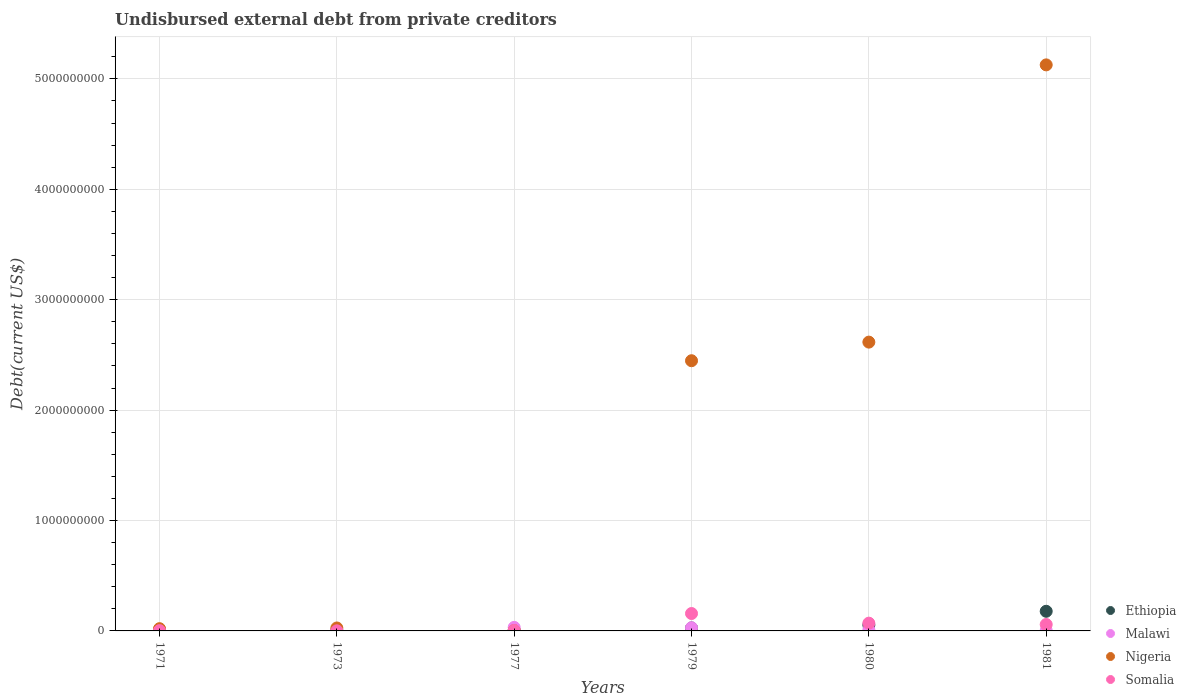How many different coloured dotlines are there?
Your answer should be very brief. 4. Is the number of dotlines equal to the number of legend labels?
Provide a succinct answer. Yes. What is the total debt in Ethiopia in 1980?
Provide a succinct answer. 5.35e+07. Across all years, what is the maximum total debt in Malawi?
Provide a succinct answer. 3.21e+07. Across all years, what is the minimum total debt in Somalia?
Keep it short and to the point. 1.00e+06. In which year was the total debt in Somalia maximum?
Offer a very short reply. 1979. In which year was the total debt in Ethiopia minimum?
Keep it short and to the point. 1971. What is the total total debt in Somalia in the graph?
Offer a terse response. 2.94e+08. What is the difference between the total debt in Malawi in 1971 and that in 1980?
Ensure brevity in your answer.  -3.56e+06. What is the difference between the total debt in Somalia in 1973 and the total debt in Ethiopia in 1977?
Offer a terse response. -5.89e+06. What is the average total debt in Malawi per year?
Offer a terse response. 1.36e+07. In the year 1973, what is the difference between the total debt in Somalia and total debt in Nigeria?
Make the answer very short. -2.57e+07. In how many years, is the total debt in Ethiopia greater than 3400000000 US$?
Provide a short and direct response. 0. What is the ratio of the total debt in Malawi in 1977 to that in 1980?
Keep it short and to the point. 3.21. Is the total debt in Somalia in 1971 less than that in 1973?
Your response must be concise. No. Is the difference between the total debt in Somalia in 1977 and 1979 greater than the difference between the total debt in Nigeria in 1977 and 1979?
Make the answer very short. Yes. What is the difference between the highest and the second highest total debt in Malawi?
Provide a short and direct response. 3.46e+06. What is the difference between the highest and the lowest total debt in Malawi?
Make the answer very short. 3.18e+07. Is the sum of the total debt in Malawi in 1973 and 1981 greater than the maximum total debt in Nigeria across all years?
Provide a succinct answer. No. Is it the case that in every year, the sum of the total debt in Somalia and total debt in Nigeria  is greater than the sum of total debt in Malawi and total debt in Ethiopia?
Give a very brief answer. No. How many dotlines are there?
Offer a terse response. 4. What is the difference between two consecutive major ticks on the Y-axis?
Make the answer very short. 1.00e+09. Does the graph contain any zero values?
Offer a very short reply. No. Does the graph contain grids?
Give a very brief answer. Yes. Where does the legend appear in the graph?
Provide a succinct answer. Bottom right. How many legend labels are there?
Provide a short and direct response. 4. What is the title of the graph?
Your answer should be compact. Undisbursed external debt from private creditors. Does "Palau" appear as one of the legend labels in the graph?
Provide a succinct answer. No. What is the label or title of the Y-axis?
Keep it short and to the point. Debt(current US$). What is the Debt(current US$) in Ethiopia in 1971?
Offer a very short reply. 1.16e+06. What is the Debt(current US$) of Malawi in 1971?
Ensure brevity in your answer.  6.45e+06. What is the Debt(current US$) of Nigeria in 1971?
Your response must be concise. 2.04e+07. What is the Debt(current US$) of Somalia in 1971?
Ensure brevity in your answer.  2.71e+06. What is the Debt(current US$) in Ethiopia in 1973?
Provide a succinct answer. 4.57e+06. What is the Debt(current US$) in Malawi in 1973?
Keep it short and to the point. 3.12e+05. What is the Debt(current US$) of Nigeria in 1973?
Provide a succinct answer. 2.67e+07. What is the Debt(current US$) in Somalia in 1973?
Offer a terse response. 1.00e+06. What is the Debt(current US$) in Ethiopia in 1977?
Ensure brevity in your answer.  6.89e+06. What is the Debt(current US$) of Malawi in 1977?
Your answer should be very brief. 3.21e+07. What is the Debt(current US$) in Nigeria in 1977?
Your answer should be very brief. 2.79e+06. What is the Debt(current US$) in Somalia in 1977?
Your response must be concise. 4.53e+06. What is the Debt(current US$) of Ethiopia in 1979?
Your response must be concise. 2.71e+07. What is the Debt(current US$) in Malawi in 1979?
Your answer should be compact. 2.87e+07. What is the Debt(current US$) in Nigeria in 1979?
Your response must be concise. 2.45e+09. What is the Debt(current US$) in Somalia in 1979?
Provide a short and direct response. 1.58e+08. What is the Debt(current US$) in Ethiopia in 1980?
Keep it short and to the point. 5.35e+07. What is the Debt(current US$) in Malawi in 1980?
Provide a succinct answer. 1.00e+07. What is the Debt(current US$) in Nigeria in 1980?
Keep it short and to the point. 2.62e+09. What is the Debt(current US$) of Somalia in 1980?
Make the answer very short. 7.03e+07. What is the Debt(current US$) of Ethiopia in 1981?
Your answer should be very brief. 1.78e+08. What is the Debt(current US$) of Malawi in 1981?
Provide a succinct answer. 3.81e+06. What is the Debt(current US$) in Nigeria in 1981?
Your response must be concise. 5.13e+09. What is the Debt(current US$) of Somalia in 1981?
Your response must be concise. 5.82e+07. Across all years, what is the maximum Debt(current US$) in Ethiopia?
Your answer should be very brief. 1.78e+08. Across all years, what is the maximum Debt(current US$) in Malawi?
Keep it short and to the point. 3.21e+07. Across all years, what is the maximum Debt(current US$) of Nigeria?
Provide a succinct answer. 5.13e+09. Across all years, what is the maximum Debt(current US$) in Somalia?
Offer a very short reply. 1.58e+08. Across all years, what is the minimum Debt(current US$) of Ethiopia?
Provide a short and direct response. 1.16e+06. Across all years, what is the minimum Debt(current US$) in Malawi?
Provide a short and direct response. 3.12e+05. Across all years, what is the minimum Debt(current US$) of Nigeria?
Your response must be concise. 2.79e+06. What is the total Debt(current US$) in Ethiopia in the graph?
Give a very brief answer. 2.71e+08. What is the total Debt(current US$) in Malawi in the graph?
Ensure brevity in your answer.  8.14e+07. What is the total Debt(current US$) in Nigeria in the graph?
Provide a succinct answer. 1.02e+1. What is the total Debt(current US$) of Somalia in the graph?
Your response must be concise. 2.94e+08. What is the difference between the Debt(current US$) of Ethiopia in 1971 and that in 1973?
Provide a short and direct response. -3.40e+06. What is the difference between the Debt(current US$) in Malawi in 1971 and that in 1973?
Give a very brief answer. 6.14e+06. What is the difference between the Debt(current US$) in Nigeria in 1971 and that in 1973?
Your response must be concise. -6.33e+06. What is the difference between the Debt(current US$) of Somalia in 1971 and that in 1973?
Your response must be concise. 1.71e+06. What is the difference between the Debt(current US$) of Ethiopia in 1971 and that in 1977?
Offer a terse response. -5.72e+06. What is the difference between the Debt(current US$) in Malawi in 1971 and that in 1977?
Make the answer very short. -2.57e+07. What is the difference between the Debt(current US$) in Nigeria in 1971 and that in 1977?
Keep it short and to the point. 1.76e+07. What is the difference between the Debt(current US$) of Somalia in 1971 and that in 1977?
Offer a terse response. -1.82e+06. What is the difference between the Debt(current US$) of Ethiopia in 1971 and that in 1979?
Offer a terse response. -2.60e+07. What is the difference between the Debt(current US$) in Malawi in 1971 and that in 1979?
Your response must be concise. -2.22e+07. What is the difference between the Debt(current US$) of Nigeria in 1971 and that in 1979?
Offer a terse response. -2.43e+09. What is the difference between the Debt(current US$) in Somalia in 1971 and that in 1979?
Keep it short and to the point. -1.55e+08. What is the difference between the Debt(current US$) of Ethiopia in 1971 and that in 1980?
Provide a succinct answer. -5.23e+07. What is the difference between the Debt(current US$) of Malawi in 1971 and that in 1980?
Your answer should be very brief. -3.56e+06. What is the difference between the Debt(current US$) of Nigeria in 1971 and that in 1980?
Provide a succinct answer. -2.60e+09. What is the difference between the Debt(current US$) of Somalia in 1971 and that in 1980?
Your response must be concise. -6.76e+07. What is the difference between the Debt(current US$) of Ethiopia in 1971 and that in 1981?
Make the answer very short. -1.77e+08. What is the difference between the Debt(current US$) in Malawi in 1971 and that in 1981?
Provide a short and direct response. 2.64e+06. What is the difference between the Debt(current US$) of Nigeria in 1971 and that in 1981?
Provide a succinct answer. -5.11e+09. What is the difference between the Debt(current US$) in Somalia in 1971 and that in 1981?
Your response must be concise. -5.55e+07. What is the difference between the Debt(current US$) of Ethiopia in 1973 and that in 1977?
Give a very brief answer. -2.32e+06. What is the difference between the Debt(current US$) of Malawi in 1973 and that in 1977?
Make the answer very short. -3.18e+07. What is the difference between the Debt(current US$) in Nigeria in 1973 and that in 1977?
Provide a short and direct response. 2.39e+07. What is the difference between the Debt(current US$) of Somalia in 1973 and that in 1977?
Offer a very short reply. -3.53e+06. What is the difference between the Debt(current US$) of Ethiopia in 1973 and that in 1979?
Your answer should be very brief. -2.26e+07. What is the difference between the Debt(current US$) in Malawi in 1973 and that in 1979?
Your answer should be compact. -2.84e+07. What is the difference between the Debt(current US$) in Nigeria in 1973 and that in 1979?
Give a very brief answer. -2.42e+09. What is the difference between the Debt(current US$) of Somalia in 1973 and that in 1979?
Provide a short and direct response. -1.57e+08. What is the difference between the Debt(current US$) in Ethiopia in 1973 and that in 1980?
Offer a terse response. -4.89e+07. What is the difference between the Debt(current US$) of Malawi in 1973 and that in 1980?
Your answer should be very brief. -9.70e+06. What is the difference between the Debt(current US$) of Nigeria in 1973 and that in 1980?
Provide a short and direct response. -2.59e+09. What is the difference between the Debt(current US$) of Somalia in 1973 and that in 1980?
Your answer should be very brief. -6.93e+07. What is the difference between the Debt(current US$) of Ethiopia in 1973 and that in 1981?
Your response must be concise. -1.73e+08. What is the difference between the Debt(current US$) of Malawi in 1973 and that in 1981?
Ensure brevity in your answer.  -3.50e+06. What is the difference between the Debt(current US$) of Nigeria in 1973 and that in 1981?
Your answer should be very brief. -5.10e+09. What is the difference between the Debt(current US$) in Somalia in 1973 and that in 1981?
Keep it short and to the point. -5.72e+07. What is the difference between the Debt(current US$) of Ethiopia in 1977 and that in 1979?
Make the answer very short. -2.02e+07. What is the difference between the Debt(current US$) of Malawi in 1977 and that in 1979?
Keep it short and to the point. 3.46e+06. What is the difference between the Debt(current US$) of Nigeria in 1977 and that in 1979?
Provide a succinct answer. -2.44e+09. What is the difference between the Debt(current US$) of Somalia in 1977 and that in 1979?
Provide a succinct answer. -1.53e+08. What is the difference between the Debt(current US$) of Ethiopia in 1977 and that in 1980?
Provide a short and direct response. -4.66e+07. What is the difference between the Debt(current US$) in Malawi in 1977 and that in 1980?
Ensure brevity in your answer.  2.21e+07. What is the difference between the Debt(current US$) of Nigeria in 1977 and that in 1980?
Your answer should be very brief. -2.61e+09. What is the difference between the Debt(current US$) in Somalia in 1977 and that in 1980?
Make the answer very short. -6.58e+07. What is the difference between the Debt(current US$) of Ethiopia in 1977 and that in 1981?
Provide a short and direct response. -1.71e+08. What is the difference between the Debt(current US$) of Malawi in 1977 and that in 1981?
Offer a very short reply. 2.83e+07. What is the difference between the Debt(current US$) of Nigeria in 1977 and that in 1981?
Offer a terse response. -5.12e+09. What is the difference between the Debt(current US$) in Somalia in 1977 and that in 1981?
Provide a short and direct response. -5.37e+07. What is the difference between the Debt(current US$) in Ethiopia in 1979 and that in 1980?
Provide a succinct answer. -2.64e+07. What is the difference between the Debt(current US$) in Malawi in 1979 and that in 1980?
Offer a terse response. 1.87e+07. What is the difference between the Debt(current US$) of Nigeria in 1979 and that in 1980?
Your response must be concise. -1.69e+08. What is the difference between the Debt(current US$) of Somalia in 1979 and that in 1980?
Your response must be concise. 8.73e+07. What is the difference between the Debt(current US$) of Ethiopia in 1979 and that in 1981?
Keep it short and to the point. -1.51e+08. What is the difference between the Debt(current US$) in Malawi in 1979 and that in 1981?
Provide a succinct answer. 2.49e+07. What is the difference between the Debt(current US$) in Nigeria in 1979 and that in 1981?
Make the answer very short. -2.68e+09. What is the difference between the Debt(current US$) in Somalia in 1979 and that in 1981?
Make the answer very short. 9.94e+07. What is the difference between the Debt(current US$) of Ethiopia in 1980 and that in 1981?
Make the answer very short. -1.24e+08. What is the difference between the Debt(current US$) of Malawi in 1980 and that in 1981?
Provide a succinct answer. 6.20e+06. What is the difference between the Debt(current US$) in Nigeria in 1980 and that in 1981?
Your answer should be very brief. -2.51e+09. What is the difference between the Debt(current US$) of Somalia in 1980 and that in 1981?
Provide a short and direct response. 1.21e+07. What is the difference between the Debt(current US$) of Ethiopia in 1971 and the Debt(current US$) of Malawi in 1973?
Your answer should be very brief. 8.53e+05. What is the difference between the Debt(current US$) in Ethiopia in 1971 and the Debt(current US$) in Nigeria in 1973?
Keep it short and to the point. -2.55e+07. What is the difference between the Debt(current US$) of Ethiopia in 1971 and the Debt(current US$) of Somalia in 1973?
Your answer should be compact. 1.65e+05. What is the difference between the Debt(current US$) of Malawi in 1971 and the Debt(current US$) of Nigeria in 1973?
Ensure brevity in your answer.  -2.02e+07. What is the difference between the Debt(current US$) in Malawi in 1971 and the Debt(current US$) in Somalia in 1973?
Give a very brief answer. 5.45e+06. What is the difference between the Debt(current US$) of Nigeria in 1971 and the Debt(current US$) of Somalia in 1973?
Offer a very short reply. 1.94e+07. What is the difference between the Debt(current US$) of Ethiopia in 1971 and the Debt(current US$) of Malawi in 1977?
Your answer should be compact. -3.10e+07. What is the difference between the Debt(current US$) of Ethiopia in 1971 and the Debt(current US$) of Nigeria in 1977?
Ensure brevity in your answer.  -1.62e+06. What is the difference between the Debt(current US$) of Ethiopia in 1971 and the Debt(current US$) of Somalia in 1977?
Your answer should be very brief. -3.36e+06. What is the difference between the Debt(current US$) in Malawi in 1971 and the Debt(current US$) in Nigeria in 1977?
Keep it short and to the point. 3.66e+06. What is the difference between the Debt(current US$) in Malawi in 1971 and the Debt(current US$) in Somalia in 1977?
Provide a succinct answer. 1.92e+06. What is the difference between the Debt(current US$) of Nigeria in 1971 and the Debt(current US$) of Somalia in 1977?
Offer a very short reply. 1.58e+07. What is the difference between the Debt(current US$) of Ethiopia in 1971 and the Debt(current US$) of Malawi in 1979?
Your answer should be compact. -2.75e+07. What is the difference between the Debt(current US$) of Ethiopia in 1971 and the Debt(current US$) of Nigeria in 1979?
Keep it short and to the point. -2.45e+09. What is the difference between the Debt(current US$) of Ethiopia in 1971 and the Debt(current US$) of Somalia in 1979?
Keep it short and to the point. -1.56e+08. What is the difference between the Debt(current US$) in Malawi in 1971 and the Debt(current US$) in Nigeria in 1979?
Provide a succinct answer. -2.44e+09. What is the difference between the Debt(current US$) in Malawi in 1971 and the Debt(current US$) in Somalia in 1979?
Provide a short and direct response. -1.51e+08. What is the difference between the Debt(current US$) of Nigeria in 1971 and the Debt(current US$) of Somalia in 1979?
Provide a short and direct response. -1.37e+08. What is the difference between the Debt(current US$) in Ethiopia in 1971 and the Debt(current US$) in Malawi in 1980?
Your answer should be very brief. -8.84e+06. What is the difference between the Debt(current US$) of Ethiopia in 1971 and the Debt(current US$) of Nigeria in 1980?
Offer a very short reply. -2.61e+09. What is the difference between the Debt(current US$) of Ethiopia in 1971 and the Debt(current US$) of Somalia in 1980?
Offer a very short reply. -6.92e+07. What is the difference between the Debt(current US$) in Malawi in 1971 and the Debt(current US$) in Nigeria in 1980?
Provide a short and direct response. -2.61e+09. What is the difference between the Debt(current US$) in Malawi in 1971 and the Debt(current US$) in Somalia in 1980?
Offer a terse response. -6.39e+07. What is the difference between the Debt(current US$) of Nigeria in 1971 and the Debt(current US$) of Somalia in 1980?
Your answer should be compact. -5.00e+07. What is the difference between the Debt(current US$) of Ethiopia in 1971 and the Debt(current US$) of Malawi in 1981?
Your answer should be compact. -2.65e+06. What is the difference between the Debt(current US$) in Ethiopia in 1971 and the Debt(current US$) in Nigeria in 1981?
Your response must be concise. -5.13e+09. What is the difference between the Debt(current US$) in Ethiopia in 1971 and the Debt(current US$) in Somalia in 1981?
Ensure brevity in your answer.  -5.70e+07. What is the difference between the Debt(current US$) in Malawi in 1971 and the Debt(current US$) in Nigeria in 1981?
Your answer should be compact. -5.12e+09. What is the difference between the Debt(current US$) in Malawi in 1971 and the Debt(current US$) in Somalia in 1981?
Your answer should be compact. -5.17e+07. What is the difference between the Debt(current US$) in Nigeria in 1971 and the Debt(current US$) in Somalia in 1981?
Provide a short and direct response. -3.78e+07. What is the difference between the Debt(current US$) of Ethiopia in 1973 and the Debt(current US$) of Malawi in 1977?
Keep it short and to the point. -2.76e+07. What is the difference between the Debt(current US$) in Ethiopia in 1973 and the Debt(current US$) in Nigeria in 1977?
Offer a very short reply. 1.78e+06. What is the difference between the Debt(current US$) in Ethiopia in 1973 and the Debt(current US$) in Somalia in 1977?
Ensure brevity in your answer.  3.90e+04. What is the difference between the Debt(current US$) of Malawi in 1973 and the Debt(current US$) of Nigeria in 1977?
Ensure brevity in your answer.  -2.47e+06. What is the difference between the Debt(current US$) in Malawi in 1973 and the Debt(current US$) in Somalia in 1977?
Your answer should be very brief. -4.22e+06. What is the difference between the Debt(current US$) in Nigeria in 1973 and the Debt(current US$) in Somalia in 1977?
Make the answer very short. 2.22e+07. What is the difference between the Debt(current US$) of Ethiopia in 1973 and the Debt(current US$) of Malawi in 1979?
Offer a terse response. -2.41e+07. What is the difference between the Debt(current US$) in Ethiopia in 1973 and the Debt(current US$) in Nigeria in 1979?
Your answer should be very brief. -2.44e+09. What is the difference between the Debt(current US$) in Ethiopia in 1973 and the Debt(current US$) in Somalia in 1979?
Your answer should be very brief. -1.53e+08. What is the difference between the Debt(current US$) in Malawi in 1973 and the Debt(current US$) in Nigeria in 1979?
Offer a very short reply. -2.45e+09. What is the difference between the Debt(current US$) in Malawi in 1973 and the Debt(current US$) in Somalia in 1979?
Your response must be concise. -1.57e+08. What is the difference between the Debt(current US$) of Nigeria in 1973 and the Debt(current US$) of Somalia in 1979?
Offer a terse response. -1.31e+08. What is the difference between the Debt(current US$) of Ethiopia in 1973 and the Debt(current US$) of Malawi in 1980?
Make the answer very short. -5.44e+06. What is the difference between the Debt(current US$) in Ethiopia in 1973 and the Debt(current US$) in Nigeria in 1980?
Make the answer very short. -2.61e+09. What is the difference between the Debt(current US$) in Ethiopia in 1973 and the Debt(current US$) in Somalia in 1980?
Give a very brief answer. -6.58e+07. What is the difference between the Debt(current US$) in Malawi in 1973 and the Debt(current US$) in Nigeria in 1980?
Provide a short and direct response. -2.62e+09. What is the difference between the Debt(current US$) of Malawi in 1973 and the Debt(current US$) of Somalia in 1980?
Offer a terse response. -7.00e+07. What is the difference between the Debt(current US$) in Nigeria in 1973 and the Debt(current US$) in Somalia in 1980?
Make the answer very short. -4.36e+07. What is the difference between the Debt(current US$) in Ethiopia in 1973 and the Debt(current US$) in Malawi in 1981?
Make the answer very short. 7.56e+05. What is the difference between the Debt(current US$) of Ethiopia in 1973 and the Debt(current US$) of Nigeria in 1981?
Provide a short and direct response. -5.12e+09. What is the difference between the Debt(current US$) of Ethiopia in 1973 and the Debt(current US$) of Somalia in 1981?
Make the answer very short. -5.36e+07. What is the difference between the Debt(current US$) of Malawi in 1973 and the Debt(current US$) of Nigeria in 1981?
Your answer should be very brief. -5.13e+09. What is the difference between the Debt(current US$) of Malawi in 1973 and the Debt(current US$) of Somalia in 1981?
Make the answer very short. -5.79e+07. What is the difference between the Debt(current US$) in Nigeria in 1973 and the Debt(current US$) in Somalia in 1981?
Make the answer very short. -3.15e+07. What is the difference between the Debt(current US$) of Ethiopia in 1977 and the Debt(current US$) of Malawi in 1979?
Offer a terse response. -2.18e+07. What is the difference between the Debt(current US$) in Ethiopia in 1977 and the Debt(current US$) in Nigeria in 1979?
Your response must be concise. -2.44e+09. What is the difference between the Debt(current US$) of Ethiopia in 1977 and the Debt(current US$) of Somalia in 1979?
Offer a terse response. -1.51e+08. What is the difference between the Debt(current US$) of Malawi in 1977 and the Debt(current US$) of Nigeria in 1979?
Ensure brevity in your answer.  -2.41e+09. What is the difference between the Debt(current US$) in Malawi in 1977 and the Debt(current US$) in Somalia in 1979?
Make the answer very short. -1.25e+08. What is the difference between the Debt(current US$) in Nigeria in 1977 and the Debt(current US$) in Somalia in 1979?
Your answer should be very brief. -1.55e+08. What is the difference between the Debt(current US$) in Ethiopia in 1977 and the Debt(current US$) in Malawi in 1980?
Your answer should be compact. -3.12e+06. What is the difference between the Debt(current US$) in Ethiopia in 1977 and the Debt(current US$) in Nigeria in 1980?
Ensure brevity in your answer.  -2.61e+09. What is the difference between the Debt(current US$) in Ethiopia in 1977 and the Debt(current US$) in Somalia in 1980?
Your response must be concise. -6.34e+07. What is the difference between the Debt(current US$) of Malawi in 1977 and the Debt(current US$) of Nigeria in 1980?
Offer a terse response. -2.58e+09. What is the difference between the Debt(current US$) in Malawi in 1977 and the Debt(current US$) in Somalia in 1980?
Make the answer very short. -3.82e+07. What is the difference between the Debt(current US$) of Nigeria in 1977 and the Debt(current US$) of Somalia in 1980?
Provide a succinct answer. -6.75e+07. What is the difference between the Debt(current US$) in Ethiopia in 1977 and the Debt(current US$) in Malawi in 1981?
Your answer should be compact. 3.08e+06. What is the difference between the Debt(current US$) of Ethiopia in 1977 and the Debt(current US$) of Nigeria in 1981?
Ensure brevity in your answer.  -5.12e+09. What is the difference between the Debt(current US$) in Ethiopia in 1977 and the Debt(current US$) in Somalia in 1981?
Provide a short and direct response. -5.13e+07. What is the difference between the Debt(current US$) of Malawi in 1977 and the Debt(current US$) of Nigeria in 1981?
Your answer should be very brief. -5.09e+09. What is the difference between the Debt(current US$) of Malawi in 1977 and the Debt(current US$) of Somalia in 1981?
Offer a very short reply. -2.61e+07. What is the difference between the Debt(current US$) in Nigeria in 1977 and the Debt(current US$) in Somalia in 1981?
Ensure brevity in your answer.  -5.54e+07. What is the difference between the Debt(current US$) of Ethiopia in 1979 and the Debt(current US$) of Malawi in 1980?
Your answer should be compact. 1.71e+07. What is the difference between the Debt(current US$) of Ethiopia in 1979 and the Debt(current US$) of Nigeria in 1980?
Offer a very short reply. -2.59e+09. What is the difference between the Debt(current US$) of Ethiopia in 1979 and the Debt(current US$) of Somalia in 1980?
Offer a very short reply. -4.32e+07. What is the difference between the Debt(current US$) of Malawi in 1979 and the Debt(current US$) of Nigeria in 1980?
Offer a very short reply. -2.59e+09. What is the difference between the Debt(current US$) in Malawi in 1979 and the Debt(current US$) in Somalia in 1980?
Your answer should be very brief. -4.17e+07. What is the difference between the Debt(current US$) of Nigeria in 1979 and the Debt(current US$) of Somalia in 1980?
Provide a short and direct response. 2.38e+09. What is the difference between the Debt(current US$) in Ethiopia in 1979 and the Debt(current US$) in Malawi in 1981?
Provide a short and direct response. 2.33e+07. What is the difference between the Debt(current US$) of Ethiopia in 1979 and the Debt(current US$) of Nigeria in 1981?
Give a very brief answer. -5.10e+09. What is the difference between the Debt(current US$) of Ethiopia in 1979 and the Debt(current US$) of Somalia in 1981?
Offer a very short reply. -3.11e+07. What is the difference between the Debt(current US$) of Malawi in 1979 and the Debt(current US$) of Nigeria in 1981?
Provide a succinct answer. -5.10e+09. What is the difference between the Debt(current US$) in Malawi in 1979 and the Debt(current US$) in Somalia in 1981?
Provide a succinct answer. -2.95e+07. What is the difference between the Debt(current US$) in Nigeria in 1979 and the Debt(current US$) in Somalia in 1981?
Ensure brevity in your answer.  2.39e+09. What is the difference between the Debt(current US$) in Ethiopia in 1980 and the Debt(current US$) in Malawi in 1981?
Your response must be concise. 4.97e+07. What is the difference between the Debt(current US$) in Ethiopia in 1980 and the Debt(current US$) in Nigeria in 1981?
Offer a very short reply. -5.07e+09. What is the difference between the Debt(current US$) of Ethiopia in 1980 and the Debt(current US$) of Somalia in 1981?
Offer a very short reply. -4.69e+06. What is the difference between the Debt(current US$) in Malawi in 1980 and the Debt(current US$) in Nigeria in 1981?
Keep it short and to the point. -5.12e+09. What is the difference between the Debt(current US$) of Malawi in 1980 and the Debt(current US$) of Somalia in 1981?
Ensure brevity in your answer.  -4.82e+07. What is the difference between the Debt(current US$) of Nigeria in 1980 and the Debt(current US$) of Somalia in 1981?
Ensure brevity in your answer.  2.56e+09. What is the average Debt(current US$) in Ethiopia per year?
Your answer should be very brief. 4.52e+07. What is the average Debt(current US$) of Malawi per year?
Keep it short and to the point. 1.36e+07. What is the average Debt(current US$) of Nigeria per year?
Keep it short and to the point. 1.71e+09. What is the average Debt(current US$) of Somalia per year?
Keep it short and to the point. 4.91e+07. In the year 1971, what is the difference between the Debt(current US$) in Ethiopia and Debt(current US$) in Malawi?
Offer a very short reply. -5.28e+06. In the year 1971, what is the difference between the Debt(current US$) of Ethiopia and Debt(current US$) of Nigeria?
Your response must be concise. -1.92e+07. In the year 1971, what is the difference between the Debt(current US$) of Ethiopia and Debt(current US$) of Somalia?
Your response must be concise. -1.54e+06. In the year 1971, what is the difference between the Debt(current US$) of Malawi and Debt(current US$) of Nigeria?
Make the answer very short. -1.39e+07. In the year 1971, what is the difference between the Debt(current US$) in Malawi and Debt(current US$) in Somalia?
Ensure brevity in your answer.  3.74e+06. In the year 1971, what is the difference between the Debt(current US$) of Nigeria and Debt(current US$) of Somalia?
Ensure brevity in your answer.  1.77e+07. In the year 1973, what is the difference between the Debt(current US$) of Ethiopia and Debt(current US$) of Malawi?
Make the answer very short. 4.26e+06. In the year 1973, what is the difference between the Debt(current US$) of Ethiopia and Debt(current US$) of Nigeria?
Provide a short and direct response. -2.21e+07. In the year 1973, what is the difference between the Debt(current US$) in Ethiopia and Debt(current US$) in Somalia?
Keep it short and to the point. 3.57e+06. In the year 1973, what is the difference between the Debt(current US$) of Malawi and Debt(current US$) of Nigeria?
Your answer should be very brief. -2.64e+07. In the year 1973, what is the difference between the Debt(current US$) of Malawi and Debt(current US$) of Somalia?
Provide a short and direct response. -6.88e+05. In the year 1973, what is the difference between the Debt(current US$) in Nigeria and Debt(current US$) in Somalia?
Provide a short and direct response. 2.57e+07. In the year 1977, what is the difference between the Debt(current US$) of Ethiopia and Debt(current US$) of Malawi?
Provide a short and direct response. -2.52e+07. In the year 1977, what is the difference between the Debt(current US$) of Ethiopia and Debt(current US$) of Nigeria?
Offer a terse response. 4.10e+06. In the year 1977, what is the difference between the Debt(current US$) of Ethiopia and Debt(current US$) of Somalia?
Offer a terse response. 2.36e+06. In the year 1977, what is the difference between the Debt(current US$) in Malawi and Debt(current US$) in Nigeria?
Your answer should be compact. 2.93e+07. In the year 1977, what is the difference between the Debt(current US$) in Malawi and Debt(current US$) in Somalia?
Provide a short and direct response. 2.76e+07. In the year 1977, what is the difference between the Debt(current US$) in Nigeria and Debt(current US$) in Somalia?
Provide a succinct answer. -1.74e+06. In the year 1979, what is the difference between the Debt(current US$) in Ethiopia and Debt(current US$) in Malawi?
Make the answer very short. -1.54e+06. In the year 1979, what is the difference between the Debt(current US$) in Ethiopia and Debt(current US$) in Nigeria?
Give a very brief answer. -2.42e+09. In the year 1979, what is the difference between the Debt(current US$) in Ethiopia and Debt(current US$) in Somalia?
Make the answer very short. -1.30e+08. In the year 1979, what is the difference between the Debt(current US$) in Malawi and Debt(current US$) in Nigeria?
Provide a succinct answer. -2.42e+09. In the year 1979, what is the difference between the Debt(current US$) in Malawi and Debt(current US$) in Somalia?
Make the answer very short. -1.29e+08. In the year 1979, what is the difference between the Debt(current US$) of Nigeria and Debt(current US$) of Somalia?
Your response must be concise. 2.29e+09. In the year 1980, what is the difference between the Debt(current US$) in Ethiopia and Debt(current US$) in Malawi?
Keep it short and to the point. 4.35e+07. In the year 1980, what is the difference between the Debt(current US$) in Ethiopia and Debt(current US$) in Nigeria?
Ensure brevity in your answer.  -2.56e+09. In the year 1980, what is the difference between the Debt(current US$) of Ethiopia and Debt(current US$) of Somalia?
Ensure brevity in your answer.  -1.68e+07. In the year 1980, what is the difference between the Debt(current US$) of Malawi and Debt(current US$) of Nigeria?
Provide a succinct answer. -2.61e+09. In the year 1980, what is the difference between the Debt(current US$) of Malawi and Debt(current US$) of Somalia?
Offer a terse response. -6.03e+07. In the year 1980, what is the difference between the Debt(current US$) of Nigeria and Debt(current US$) of Somalia?
Your answer should be compact. 2.55e+09. In the year 1981, what is the difference between the Debt(current US$) in Ethiopia and Debt(current US$) in Malawi?
Provide a short and direct response. 1.74e+08. In the year 1981, what is the difference between the Debt(current US$) in Ethiopia and Debt(current US$) in Nigeria?
Your answer should be compact. -4.95e+09. In the year 1981, what is the difference between the Debt(current US$) of Ethiopia and Debt(current US$) of Somalia?
Offer a terse response. 1.20e+08. In the year 1981, what is the difference between the Debt(current US$) in Malawi and Debt(current US$) in Nigeria?
Your answer should be very brief. -5.12e+09. In the year 1981, what is the difference between the Debt(current US$) in Malawi and Debt(current US$) in Somalia?
Your answer should be compact. -5.44e+07. In the year 1981, what is the difference between the Debt(current US$) of Nigeria and Debt(current US$) of Somalia?
Your answer should be very brief. 5.07e+09. What is the ratio of the Debt(current US$) in Ethiopia in 1971 to that in 1973?
Your answer should be very brief. 0.26. What is the ratio of the Debt(current US$) of Malawi in 1971 to that in 1973?
Provide a short and direct response. 20.67. What is the ratio of the Debt(current US$) in Nigeria in 1971 to that in 1973?
Your answer should be compact. 0.76. What is the ratio of the Debt(current US$) in Somalia in 1971 to that in 1973?
Your answer should be very brief. 2.71. What is the ratio of the Debt(current US$) of Ethiopia in 1971 to that in 1977?
Provide a short and direct response. 0.17. What is the ratio of the Debt(current US$) of Malawi in 1971 to that in 1977?
Your response must be concise. 0.2. What is the ratio of the Debt(current US$) in Nigeria in 1971 to that in 1977?
Ensure brevity in your answer.  7.31. What is the ratio of the Debt(current US$) of Somalia in 1971 to that in 1977?
Offer a very short reply. 0.6. What is the ratio of the Debt(current US$) in Ethiopia in 1971 to that in 1979?
Keep it short and to the point. 0.04. What is the ratio of the Debt(current US$) of Malawi in 1971 to that in 1979?
Ensure brevity in your answer.  0.23. What is the ratio of the Debt(current US$) in Nigeria in 1971 to that in 1979?
Offer a terse response. 0.01. What is the ratio of the Debt(current US$) of Somalia in 1971 to that in 1979?
Your answer should be very brief. 0.02. What is the ratio of the Debt(current US$) in Ethiopia in 1971 to that in 1980?
Provide a short and direct response. 0.02. What is the ratio of the Debt(current US$) of Malawi in 1971 to that in 1980?
Provide a succinct answer. 0.64. What is the ratio of the Debt(current US$) of Nigeria in 1971 to that in 1980?
Give a very brief answer. 0.01. What is the ratio of the Debt(current US$) of Somalia in 1971 to that in 1980?
Your answer should be very brief. 0.04. What is the ratio of the Debt(current US$) of Ethiopia in 1971 to that in 1981?
Make the answer very short. 0.01. What is the ratio of the Debt(current US$) in Malawi in 1971 to that in 1981?
Keep it short and to the point. 1.69. What is the ratio of the Debt(current US$) in Nigeria in 1971 to that in 1981?
Ensure brevity in your answer.  0. What is the ratio of the Debt(current US$) in Somalia in 1971 to that in 1981?
Provide a succinct answer. 0.05. What is the ratio of the Debt(current US$) of Ethiopia in 1973 to that in 1977?
Keep it short and to the point. 0.66. What is the ratio of the Debt(current US$) in Malawi in 1973 to that in 1977?
Provide a succinct answer. 0.01. What is the ratio of the Debt(current US$) in Nigeria in 1973 to that in 1977?
Make the answer very short. 9.58. What is the ratio of the Debt(current US$) of Somalia in 1973 to that in 1977?
Ensure brevity in your answer.  0.22. What is the ratio of the Debt(current US$) in Ethiopia in 1973 to that in 1979?
Offer a very short reply. 0.17. What is the ratio of the Debt(current US$) in Malawi in 1973 to that in 1979?
Make the answer very short. 0.01. What is the ratio of the Debt(current US$) of Nigeria in 1973 to that in 1979?
Make the answer very short. 0.01. What is the ratio of the Debt(current US$) of Somalia in 1973 to that in 1979?
Offer a very short reply. 0.01. What is the ratio of the Debt(current US$) of Ethiopia in 1973 to that in 1980?
Give a very brief answer. 0.09. What is the ratio of the Debt(current US$) of Malawi in 1973 to that in 1980?
Your response must be concise. 0.03. What is the ratio of the Debt(current US$) in Nigeria in 1973 to that in 1980?
Offer a terse response. 0.01. What is the ratio of the Debt(current US$) in Somalia in 1973 to that in 1980?
Ensure brevity in your answer.  0.01. What is the ratio of the Debt(current US$) in Ethiopia in 1973 to that in 1981?
Give a very brief answer. 0.03. What is the ratio of the Debt(current US$) in Malawi in 1973 to that in 1981?
Provide a short and direct response. 0.08. What is the ratio of the Debt(current US$) in Nigeria in 1973 to that in 1981?
Provide a succinct answer. 0.01. What is the ratio of the Debt(current US$) in Somalia in 1973 to that in 1981?
Provide a short and direct response. 0.02. What is the ratio of the Debt(current US$) in Ethiopia in 1977 to that in 1979?
Give a very brief answer. 0.25. What is the ratio of the Debt(current US$) of Malawi in 1977 to that in 1979?
Your answer should be very brief. 1.12. What is the ratio of the Debt(current US$) in Nigeria in 1977 to that in 1979?
Keep it short and to the point. 0. What is the ratio of the Debt(current US$) of Somalia in 1977 to that in 1979?
Keep it short and to the point. 0.03. What is the ratio of the Debt(current US$) in Ethiopia in 1977 to that in 1980?
Give a very brief answer. 0.13. What is the ratio of the Debt(current US$) in Malawi in 1977 to that in 1980?
Keep it short and to the point. 3.21. What is the ratio of the Debt(current US$) of Nigeria in 1977 to that in 1980?
Your response must be concise. 0. What is the ratio of the Debt(current US$) of Somalia in 1977 to that in 1980?
Your response must be concise. 0.06. What is the ratio of the Debt(current US$) of Ethiopia in 1977 to that in 1981?
Offer a terse response. 0.04. What is the ratio of the Debt(current US$) in Malawi in 1977 to that in 1981?
Keep it short and to the point. 8.43. What is the ratio of the Debt(current US$) in Somalia in 1977 to that in 1981?
Your answer should be very brief. 0.08. What is the ratio of the Debt(current US$) in Ethiopia in 1979 to that in 1980?
Offer a very short reply. 0.51. What is the ratio of the Debt(current US$) of Malawi in 1979 to that in 1980?
Your answer should be very brief. 2.86. What is the ratio of the Debt(current US$) of Nigeria in 1979 to that in 1980?
Give a very brief answer. 0.94. What is the ratio of the Debt(current US$) in Somalia in 1979 to that in 1980?
Offer a terse response. 2.24. What is the ratio of the Debt(current US$) in Ethiopia in 1979 to that in 1981?
Your response must be concise. 0.15. What is the ratio of the Debt(current US$) of Malawi in 1979 to that in 1981?
Provide a short and direct response. 7.52. What is the ratio of the Debt(current US$) of Nigeria in 1979 to that in 1981?
Offer a terse response. 0.48. What is the ratio of the Debt(current US$) in Somalia in 1979 to that in 1981?
Provide a succinct answer. 2.71. What is the ratio of the Debt(current US$) in Ethiopia in 1980 to that in 1981?
Your response must be concise. 0.3. What is the ratio of the Debt(current US$) in Malawi in 1980 to that in 1981?
Give a very brief answer. 2.63. What is the ratio of the Debt(current US$) of Nigeria in 1980 to that in 1981?
Make the answer very short. 0.51. What is the ratio of the Debt(current US$) in Somalia in 1980 to that in 1981?
Your answer should be very brief. 1.21. What is the difference between the highest and the second highest Debt(current US$) in Ethiopia?
Offer a very short reply. 1.24e+08. What is the difference between the highest and the second highest Debt(current US$) in Malawi?
Offer a terse response. 3.46e+06. What is the difference between the highest and the second highest Debt(current US$) in Nigeria?
Your answer should be compact. 2.51e+09. What is the difference between the highest and the second highest Debt(current US$) of Somalia?
Offer a very short reply. 8.73e+07. What is the difference between the highest and the lowest Debt(current US$) of Ethiopia?
Make the answer very short. 1.77e+08. What is the difference between the highest and the lowest Debt(current US$) of Malawi?
Your response must be concise. 3.18e+07. What is the difference between the highest and the lowest Debt(current US$) of Nigeria?
Keep it short and to the point. 5.12e+09. What is the difference between the highest and the lowest Debt(current US$) in Somalia?
Give a very brief answer. 1.57e+08. 